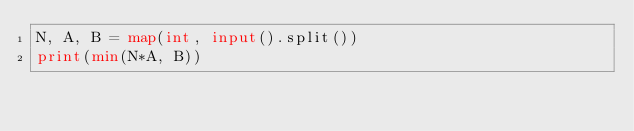<code> <loc_0><loc_0><loc_500><loc_500><_Python_>N, A, B = map(int, input().split())
print(min(N*A, B))</code> 